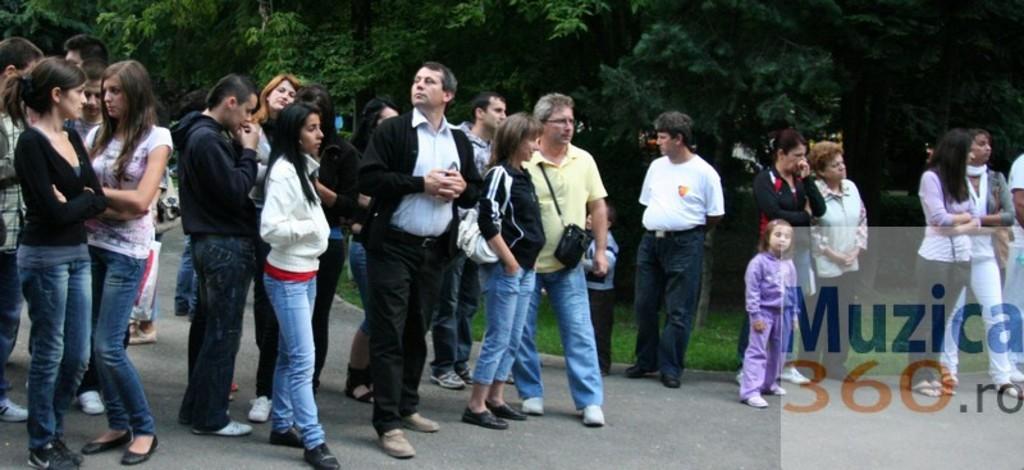Describe this image in one or two sentences. In this image, we can see people and some are wearing bags. In the background, there are trees and there is some text. 